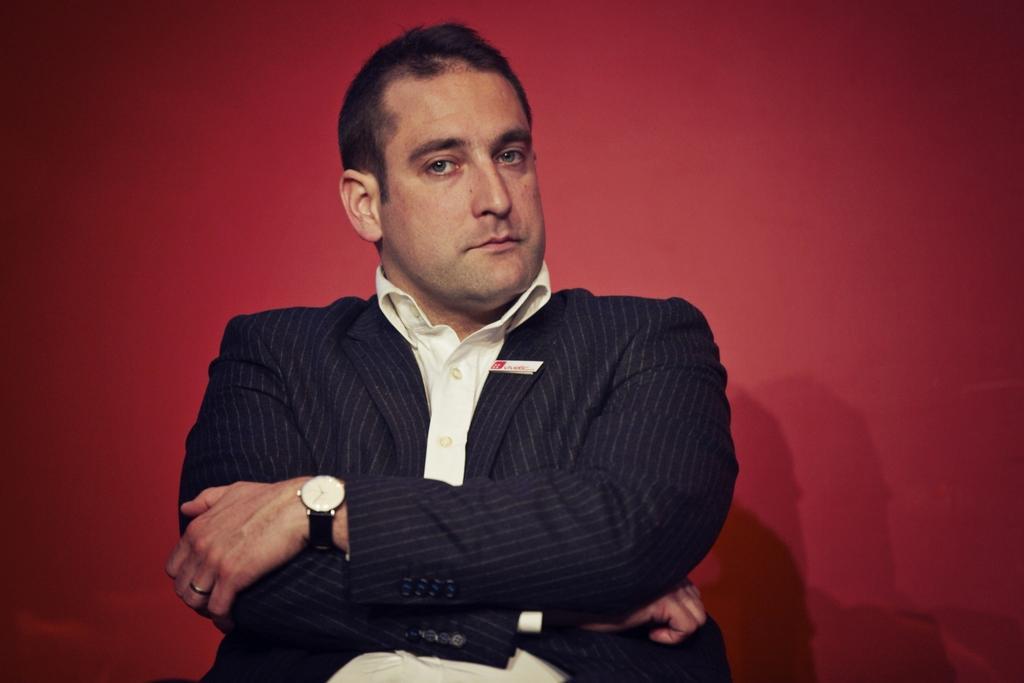How would you summarize this image in a sentence or two? In this image we can see one man in a suit sitting in the middle of the image, one batch attached to the man´s suit and there is a red background. 